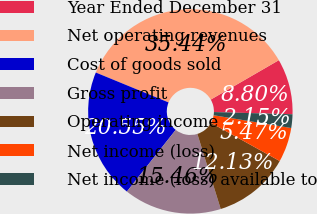Convert chart. <chart><loc_0><loc_0><loc_500><loc_500><pie_chart><fcel>Year Ended December 31<fcel>Net operating revenues<fcel>Cost of goods sold<fcel>Gross profit<fcel>Operating income<fcel>Net income (loss)<fcel>Net income (loss) available to<nl><fcel>8.8%<fcel>35.44%<fcel>20.55%<fcel>15.46%<fcel>12.13%<fcel>5.47%<fcel>2.15%<nl></chart> 